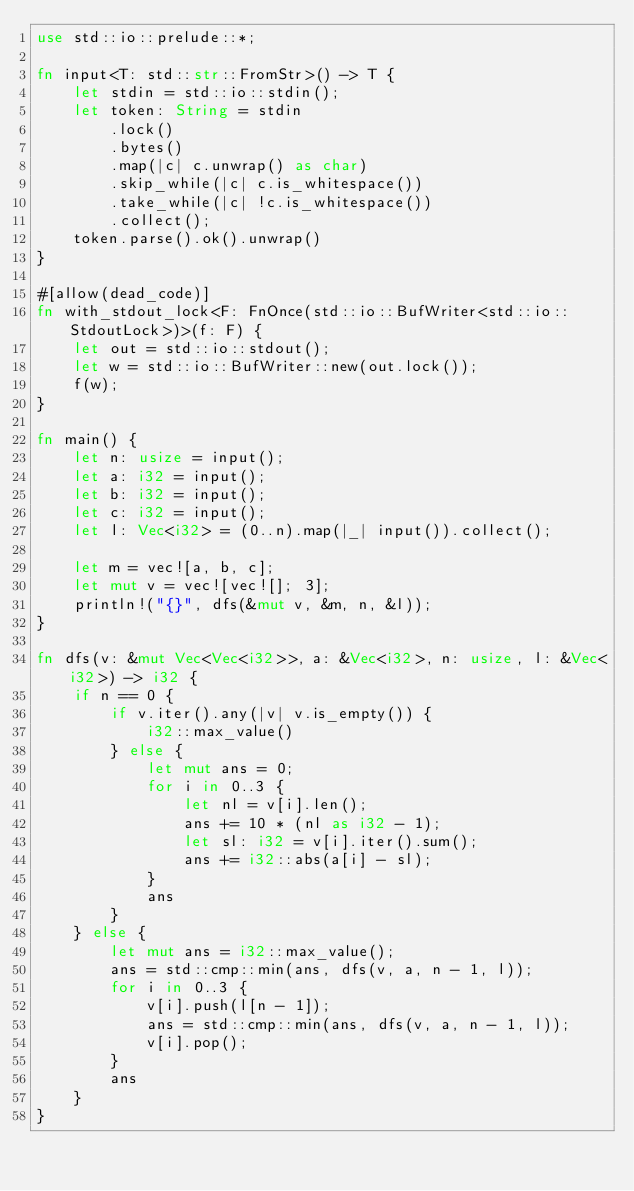Convert code to text. <code><loc_0><loc_0><loc_500><loc_500><_Rust_>use std::io::prelude::*;

fn input<T: std::str::FromStr>() -> T {
    let stdin = std::io::stdin();
    let token: String = stdin
        .lock()
        .bytes()
        .map(|c| c.unwrap() as char)
        .skip_while(|c| c.is_whitespace())
        .take_while(|c| !c.is_whitespace())
        .collect();
    token.parse().ok().unwrap()
}

#[allow(dead_code)]
fn with_stdout_lock<F: FnOnce(std::io::BufWriter<std::io::StdoutLock>)>(f: F) {
    let out = std::io::stdout();
    let w = std::io::BufWriter::new(out.lock());
    f(w);
}

fn main() {
    let n: usize = input();
    let a: i32 = input();
    let b: i32 = input();
    let c: i32 = input();
    let l: Vec<i32> = (0..n).map(|_| input()).collect();

    let m = vec![a, b, c];
    let mut v = vec![vec![]; 3];
    println!("{}", dfs(&mut v, &m, n, &l));
}

fn dfs(v: &mut Vec<Vec<i32>>, a: &Vec<i32>, n: usize, l: &Vec<i32>) -> i32 {
    if n == 0 {
        if v.iter().any(|v| v.is_empty()) {
            i32::max_value()
        } else {
            let mut ans = 0;
            for i in 0..3 {
                let nl = v[i].len();
                ans += 10 * (nl as i32 - 1);
                let sl: i32 = v[i].iter().sum();
                ans += i32::abs(a[i] - sl);
            }
            ans
        }
    } else {
        let mut ans = i32::max_value();
        ans = std::cmp::min(ans, dfs(v, a, n - 1, l));
        for i in 0..3 {
            v[i].push(l[n - 1]);
            ans = std::cmp::min(ans, dfs(v, a, n - 1, l));
            v[i].pop();
        }
        ans
    }
}
</code> 